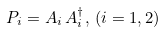<formula> <loc_0><loc_0><loc_500><loc_500>P _ { i } = A _ { i } \, A _ { i } ^ { \dagger } , \, ( i = 1 , 2 )</formula> 